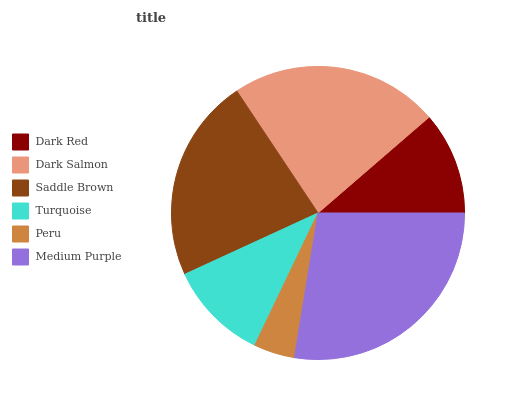Is Peru the minimum?
Answer yes or no. Yes. Is Medium Purple the maximum?
Answer yes or no. Yes. Is Dark Salmon the minimum?
Answer yes or no. No. Is Dark Salmon the maximum?
Answer yes or no. No. Is Dark Salmon greater than Dark Red?
Answer yes or no. Yes. Is Dark Red less than Dark Salmon?
Answer yes or no. Yes. Is Dark Red greater than Dark Salmon?
Answer yes or no. No. Is Dark Salmon less than Dark Red?
Answer yes or no. No. Is Saddle Brown the high median?
Answer yes or no. Yes. Is Dark Red the low median?
Answer yes or no. Yes. Is Peru the high median?
Answer yes or no. No. Is Medium Purple the low median?
Answer yes or no. No. 